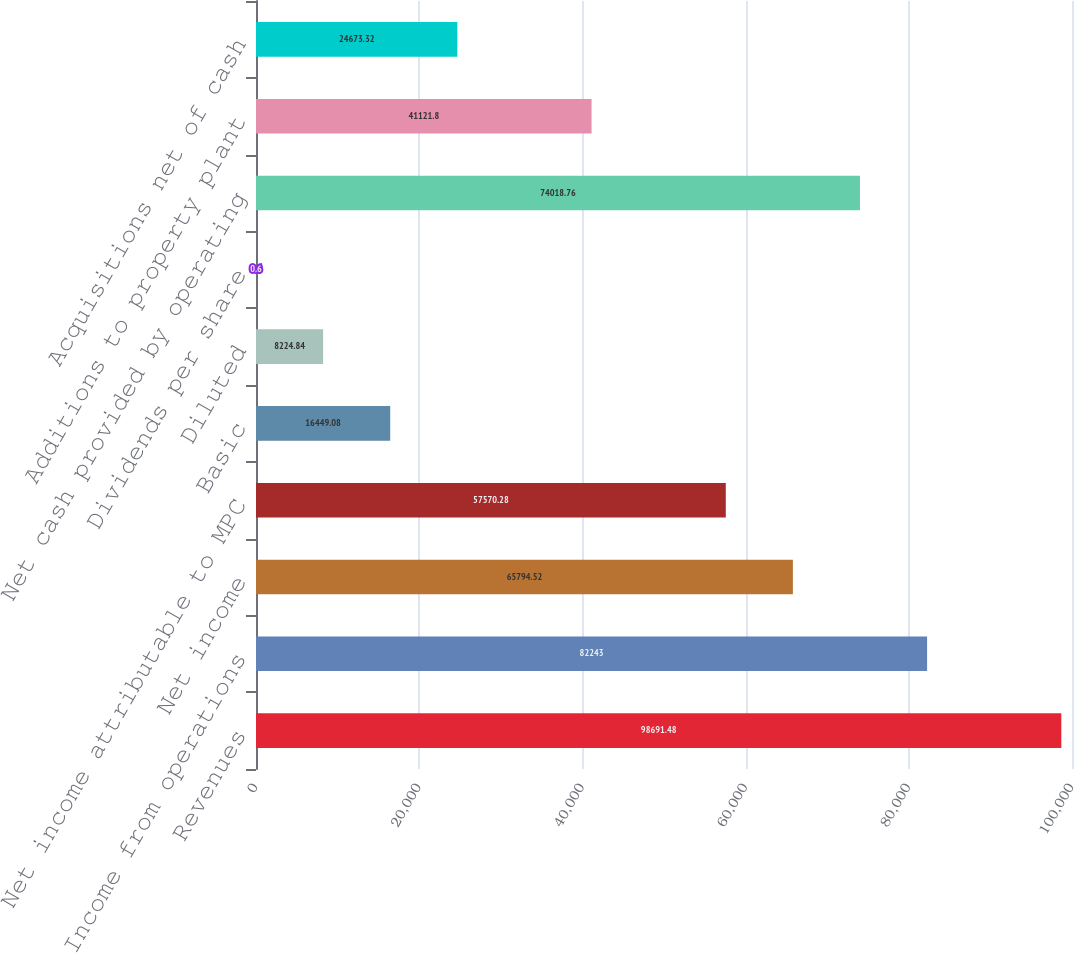<chart> <loc_0><loc_0><loc_500><loc_500><bar_chart><fcel>Revenues<fcel>Income from operations<fcel>Net income<fcel>Net income attributable to MPC<fcel>Basic<fcel>Diluted<fcel>Dividends per share<fcel>Net cash provided by operating<fcel>Additions to property plant<fcel>Acquisitions net of cash<nl><fcel>98691.5<fcel>82243<fcel>65794.5<fcel>57570.3<fcel>16449.1<fcel>8224.84<fcel>0.6<fcel>74018.8<fcel>41121.8<fcel>24673.3<nl></chart> 